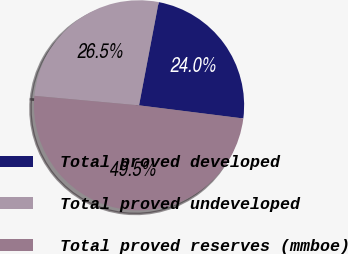Convert chart. <chart><loc_0><loc_0><loc_500><loc_500><pie_chart><fcel>Total proved developed<fcel>Total proved undeveloped<fcel>Total proved reserves (mmboe)<nl><fcel>24.0%<fcel>26.55%<fcel>49.45%<nl></chart> 